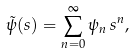Convert formula to latex. <formula><loc_0><loc_0><loc_500><loc_500>\tilde { \psi } ( s ) = \sum _ { n = 0 } ^ { \infty } \psi _ { n } \, s ^ { n } ,</formula> 